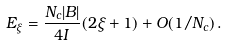<formula> <loc_0><loc_0><loc_500><loc_500>E _ { \xi } = \frac { N _ { c } | B | } { 4 I } ( 2 \xi + 1 ) + O ( 1 / N _ { c } ) \, .</formula> 